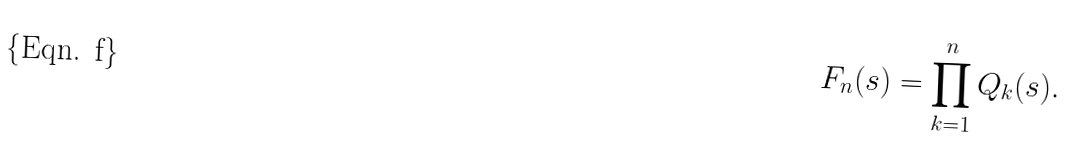Convert formula to latex. <formula><loc_0><loc_0><loc_500><loc_500>F _ { n } ( s ) = \prod _ { k = 1 } ^ { n } Q _ { k } ( s ) .</formula> 